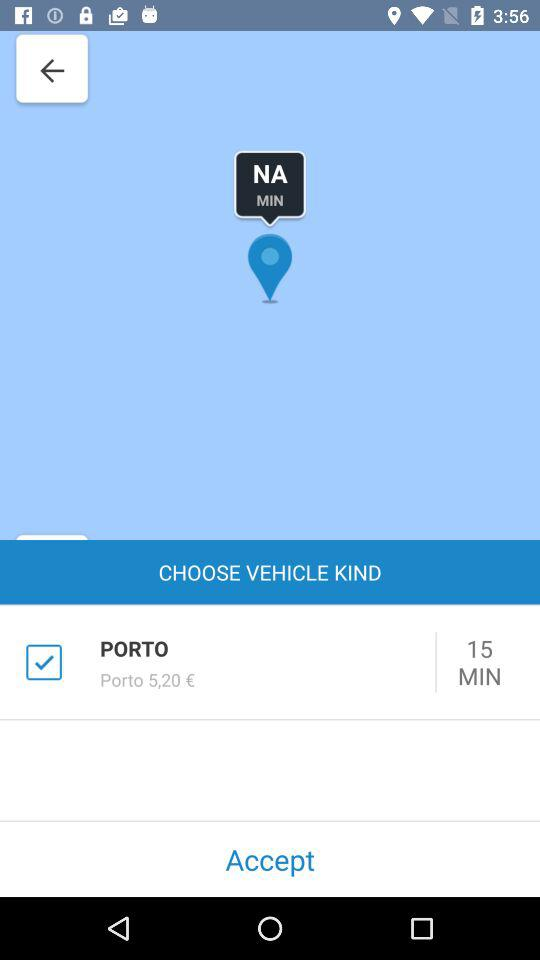What is the given price? The given price is €5,20. 